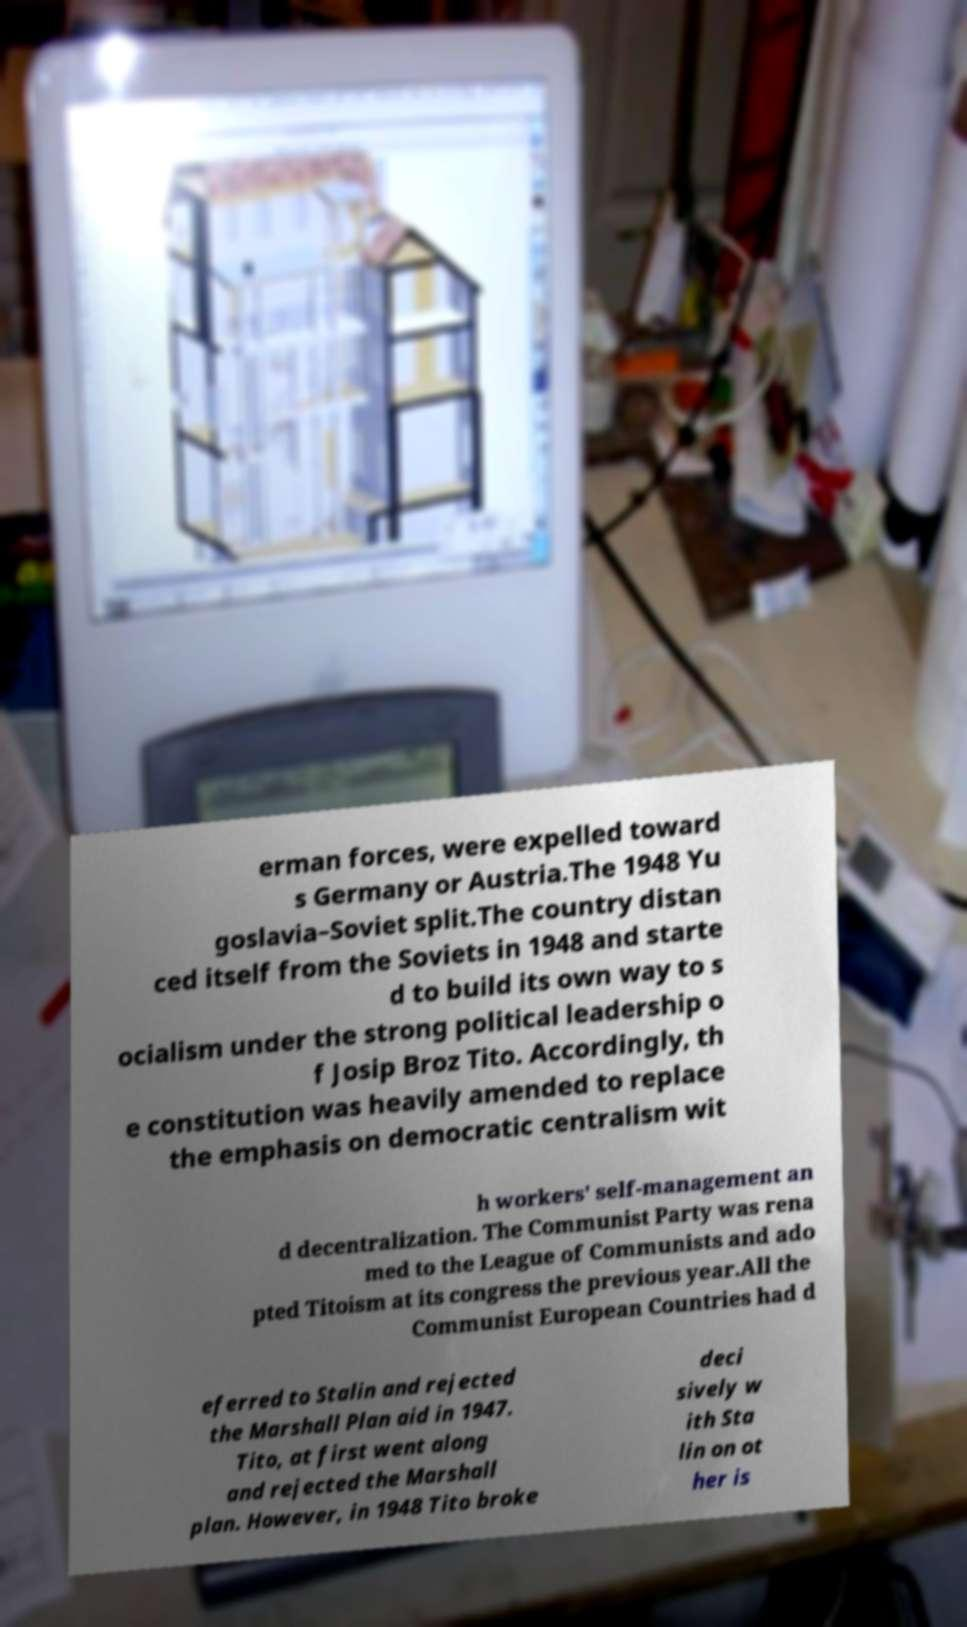Please read and relay the text visible in this image. What does it say? erman forces, were expelled toward s Germany or Austria.The 1948 Yu goslavia–Soviet split.The country distan ced itself from the Soviets in 1948 and starte d to build its own way to s ocialism under the strong political leadership o f Josip Broz Tito. Accordingly, th e constitution was heavily amended to replace the emphasis on democratic centralism wit h workers' self-management an d decentralization. The Communist Party was rena med to the League of Communists and ado pted Titoism at its congress the previous year.All the Communist European Countries had d eferred to Stalin and rejected the Marshall Plan aid in 1947. Tito, at first went along and rejected the Marshall plan. However, in 1948 Tito broke deci sively w ith Sta lin on ot her is 